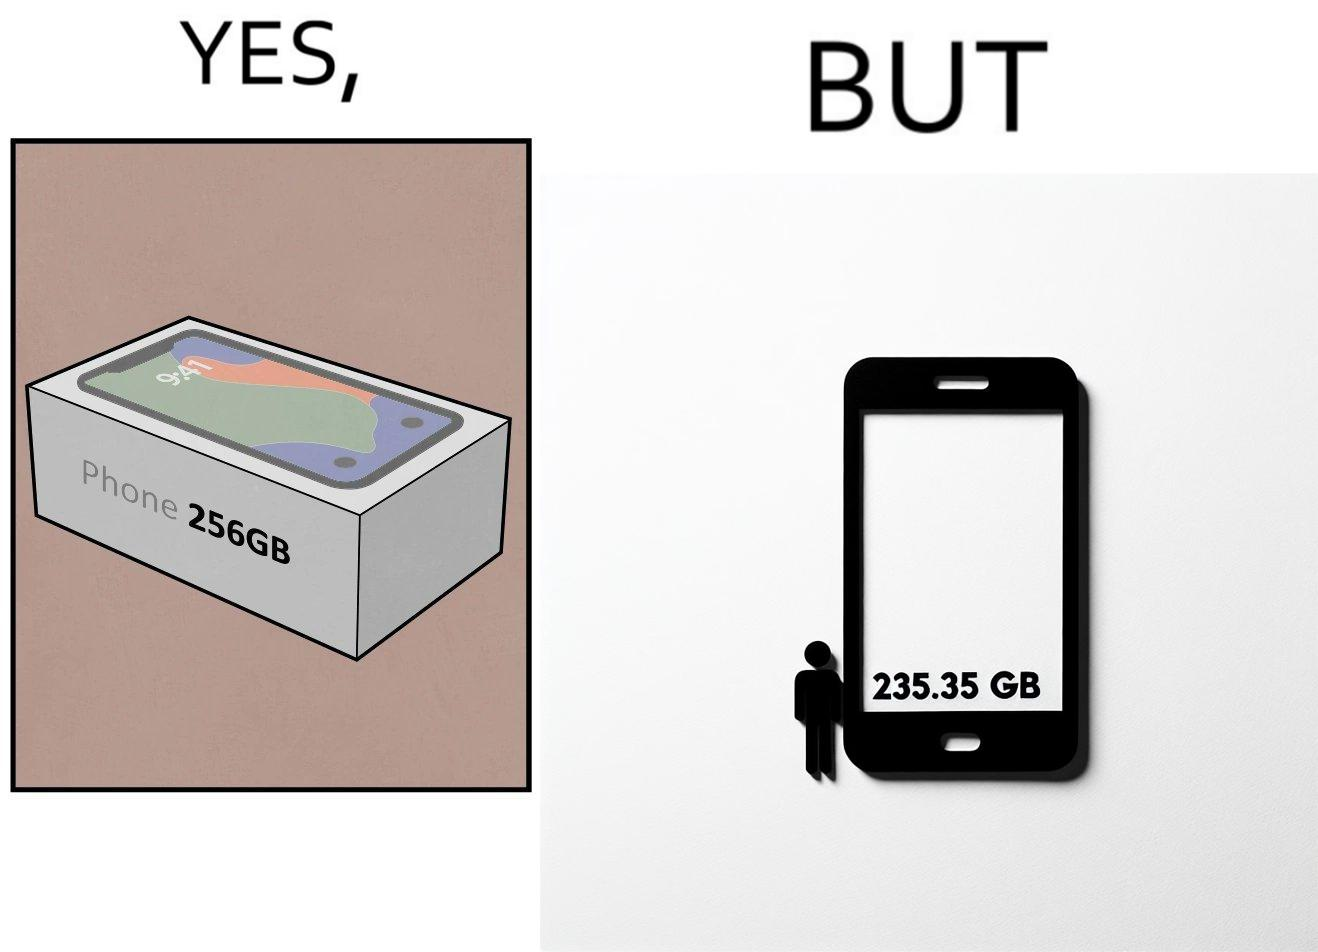Is this image satirical or non-satirical? Yes, this image is satirical. 